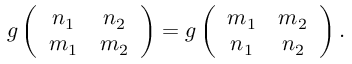<formula> <loc_0><loc_0><loc_500><loc_500>g \left ( \begin{array} { c c } { { n _ { 1 } } } & { { n _ { 2 } } } \\ { { m _ { 1 } } } & { { m _ { 2 } } } \end{array} \right ) = g \left ( \begin{array} { c c } { { m _ { 1 } } } & { { m _ { 2 } } } \\ { { n _ { 1 } } } & { { n _ { 2 } } } \end{array} \right ) .</formula> 